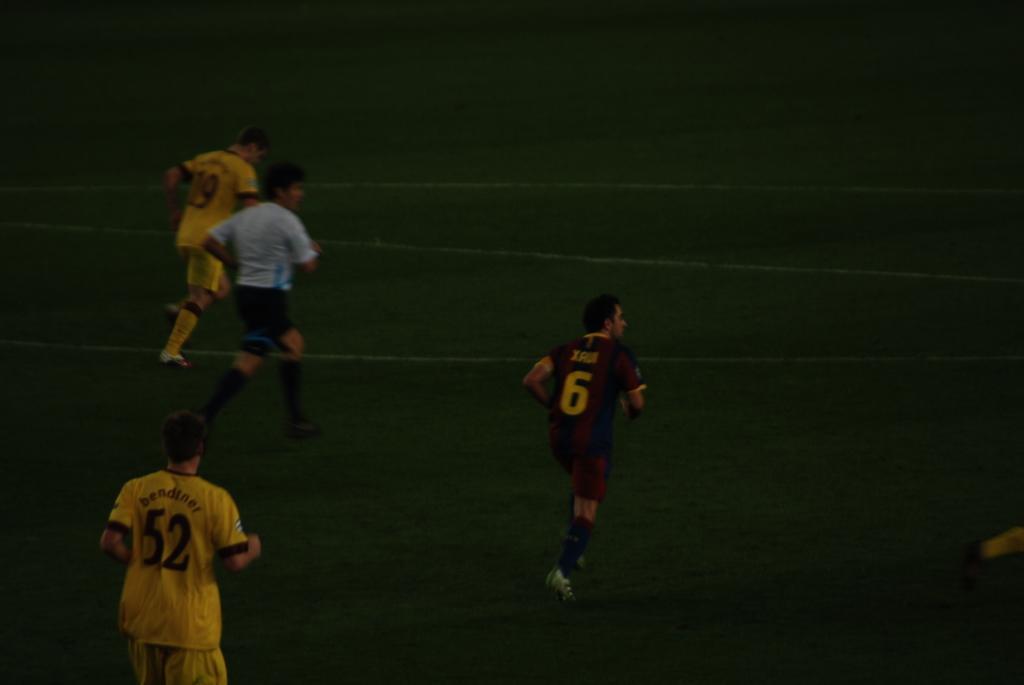Please provide a concise description of this image. In this picture I can see few people are running on the grass. 